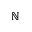Convert formula to latex. <formula><loc_0><loc_0><loc_500><loc_500>\mathbb { N }</formula> 